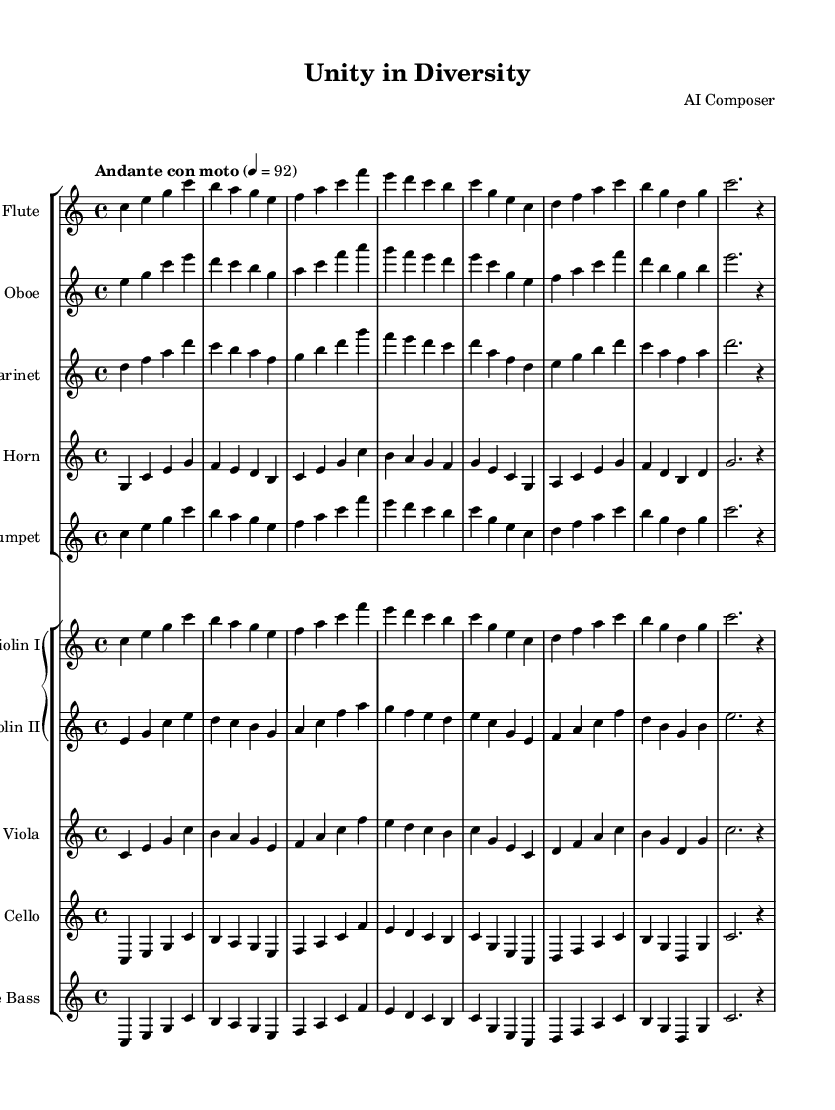What is the key signature of this music? The key signature is C major, which has no sharps or flats indicated at the beginning of the staff.
Answer: C major What is the time signature of this music? The time signature is indicated as 4/4, meaning there are four beats in a measure, and the quarter note gets one beat.
Answer: 4/4 What tempo marking is given for this piece? The tempo marking is "Andante con moto," which indicates a moderately slow tempo with a bit of movement.
Answer: Andante con moto How many measures are in the flute part? By counting the distinct groups of notes separated by vertical lines (bar lines) in the flute part, there are a total of eight measures.
Answer: Eight What instruments are featured in this orchestration? The instruments listed include flute, oboe, clarinet, horn, trumpet, two violins, viola, cello, and double bass.
Answer: Flute, Oboe, Clarinet, Horn, Trumpet, Violin I, Violin II, Viola, Cello, Double Bass Which instruments play in the same octave range as the cello? Both the viola and the double bass have parts written in the same or similar bass clef range as the cello.
Answer: Viola, Double Bass What is the notation used for expressing dynamics in this piece? There are no specific dynamic markings visible in the provided music sheet data, implying that it may rely on the conductor's interpretation.
Answer: N/A 